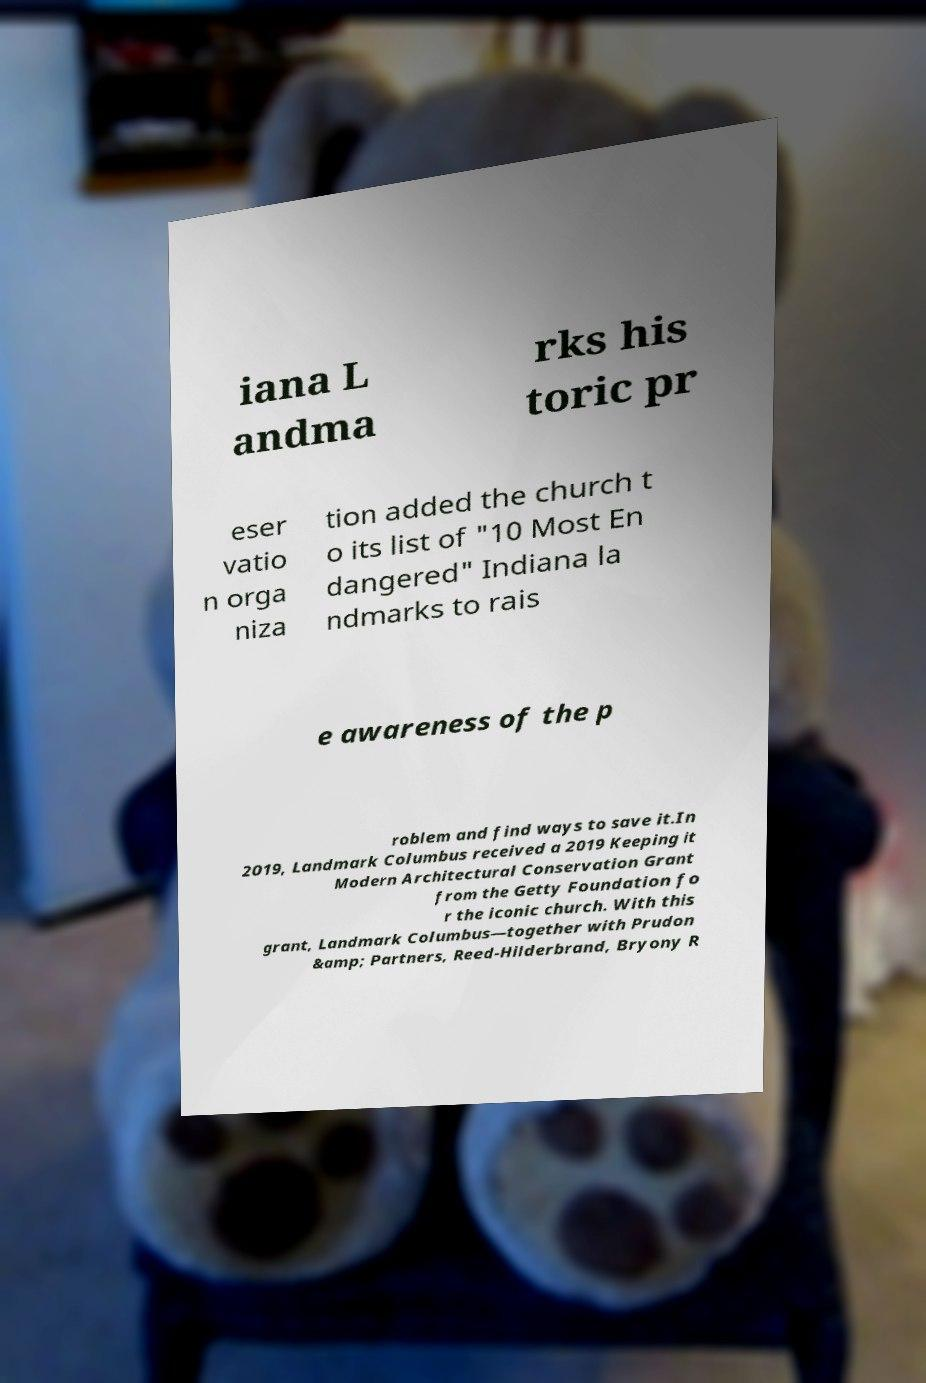Please identify and transcribe the text found in this image. iana L andma rks his toric pr eser vatio n orga niza tion added the church t o its list of "10 Most En dangered" Indiana la ndmarks to rais e awareness of the p roblem and find ways to save it.In 2019, Landmark Columbus received a 2019 Keeping it Modern Architectural Conservation Grant from the Getty Foundation fo r the iconic church. With this grant, Landmark Columbus—together with Prudon &amp; Partners, Reed-Hilderbrand, Bryony R 